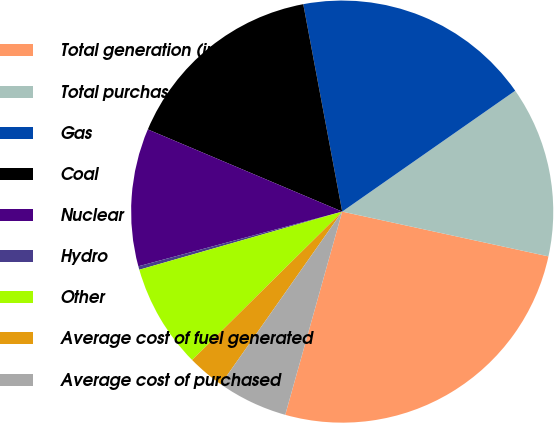<chart> <loc_0><loc_0><loc_500><loc_500><pie_chart><fcel>Total generation (in billions<fcel>Total purchased power (in<fcel>Gas<fcel>Coal<fcel>Nuclear<fcel>Hydro<fcel>Other<fcel>Average cost of fuel generated<fcel>Average cost of purchased<nl><fcel>25.95%<fcel>13.11%<fcel>18.25%<fcel>15.68%<fcel>10.54%<fcel>0.27%<fcel>7.97%<fcel>2.84%<fcel>5.4%<nl></chart> 